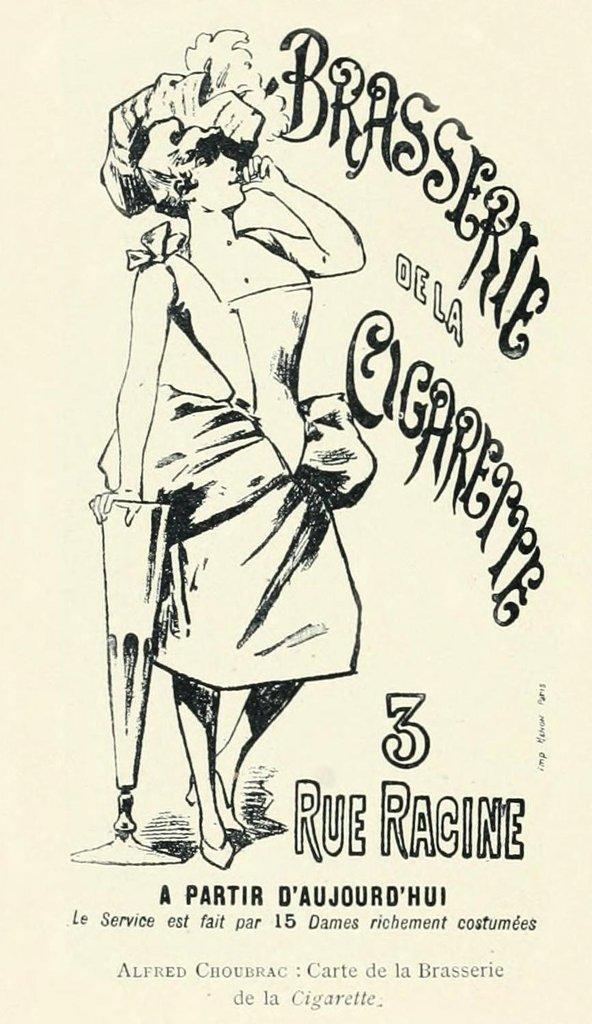How would you summarize this image in a sentence or two? This is a sketch and here we can see a person standing and holding a stand and there is some text written. 